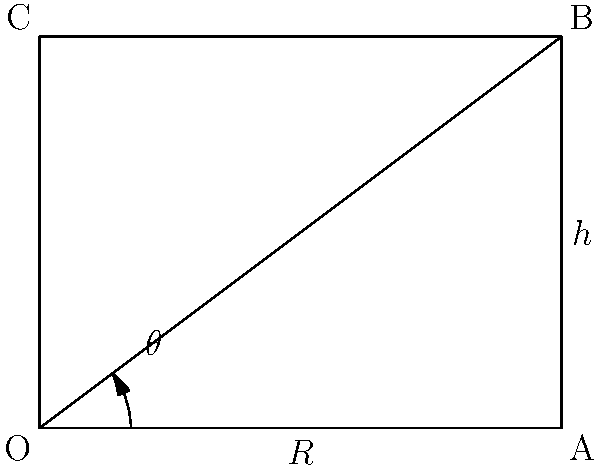In high-speed rail design, the optimal angle of track curves is crucial for balancing speed and passenger comfort. Consider a curved section of track with radius $R$ and superelevation (bank angle) $\theta$. If the track width is $h$, what is the maximum speed $v$ (in m/s) at which a train can negotiate this curve without passengers experiencing lateral discomfort, given that the comfortable lateral acceleration should not exceed $0.8 \text{ m/s}^2$?

Given:
- $R = 3000 \text{ m}$
- $h = 1.5 \text{ m}$
- $g = 9.81 \text{ m/s}^2$ (acceleration due to gravity)
- $\tan \theta = \frac{h}{2R}$

Express your answer in terms of $\sqrt{R}$. To solve this problem, we'll follow these steps:

1) First, we need to understand the forces acting on the train. There are three main forces:
   - Centripetal force due to the curve
   - Gravitational force
   - Normal force from the track

2) The comfortable lateral acceleration is given as $0.8 \text{ m/s}^2$. This is the net acceleration passengers should feel perpendicular to the direction of motion.

3) The balance of forces in the direction perpendicular to the track surface is:

   $\frac{mv^2}{R}\cos\theta - mg\sin\theta = 0.8m$

   Where $m$ is the mass of the train, $v$ is the velocity, $R$ is the radius of the curve, $g$ is the acceleration due to gravity, and $\theta$ is the superelevation angle.

4) We're given that $\tan\theta = \frac{h}{2R}$. For small angles, $\tan\theta \approx \sin\theta$, and $\cos\theta \approx 1$. Therefore:

   $\sin\theta \approx \frac{h}{2R} = \frac{1.5}{2(3000)} = 0.00025$

5) Substituting this into our force balance equation:

   $\frac{v^2}{R} - g(0.00025) = 0.8$

6) Solving for $v$:

   $v^2 = R(0.8 + g(0.00025))$
   $v^2 = R(0.8 + 9.81(0.00025))$
   $v^2 = R(0.8 + 0.002453)$
   $v^2 = 0.802453R$

7) Taking the square root of both sides:

   $v = \sqrt{0.802453R}$

8) Simplifying:

   $v \approx 0.896\sqrt{R}$

Therefore, the maximum speed is approximately $0.896\sqrt{R}$ m/s.
Answer: $0.896\sqrt{R}$ m/s 